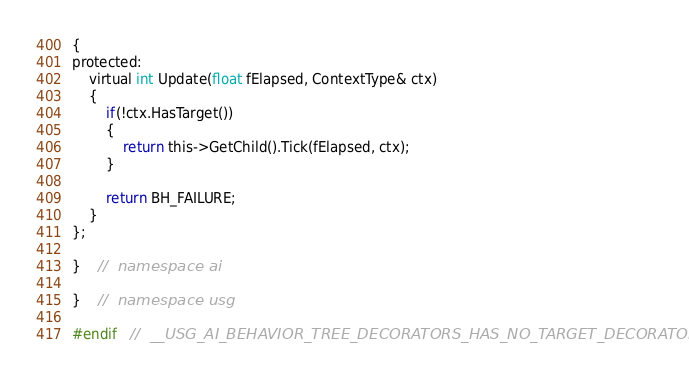<code> <loc_0><loc_0><loc_500><loc_500><_C_>{
protected:
	virtual int Update(float fElapsed, ContextType& ctx)
	{
		if(!ctx.HasTarget())
		{
			return this->GetChild().Tick(fElapsed, ctx);
		}

		return BH_FAILURE;
	}
};

}	//	namespace ai

}	//	namespace usg

#endif	//	__USG_AI_BEHAVIOR_TREE_DECORATORS_HAS_NO_TARGET_DECORATOR__
</code> 